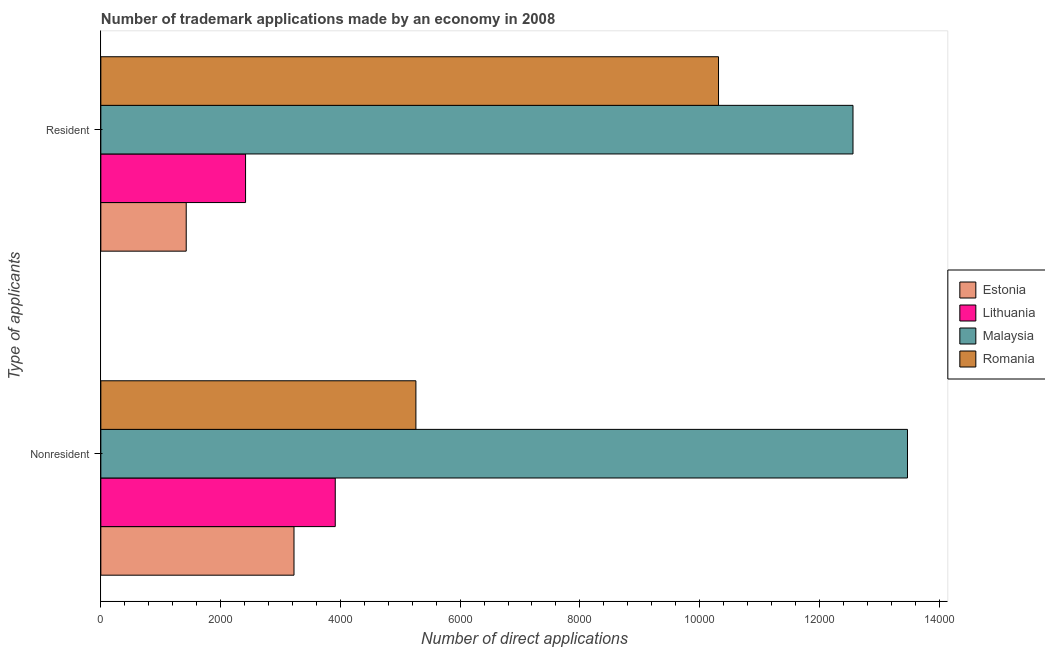How many different coloured bars are there?
Ensure brevity in your answer.  4. How many groups of bars are there?
Offer a very short reply. 2. Are the number of bars on each tick of the Y-axis equal?
Your answer should be compact. Yes. What is the label of the 1st group of bars from the top?
Keep it short and to the point. Resident. What is the number of trademark applications made by non residents in Romania?
Make the answer very short. 5262. Across all countries, what is the maximum number of trademark applications made by residents?
Give a very brief answer. 1.26e+04. Across all countries, what is the minimum number of trademark applications made by residents?
Provide a short and direct response. 1426. In which country was the number of trademark applications made by non residents maximum?
Provide a succinct answer. Malaysia. In which country was the number of trademark applications made by non residents minimum?
Keep it short and to the point. Estonia. What is the total number of trademark applications made by residents in the graph?
Make the answer very short. 2.67e+04. What is the difference between the number of trademark applications made by non residents in Malaysia and that in Estonia?
Your answer should be very brief. 1.02e+04. What is the difference between the number of trademark applications made by non residents in Estonia and the number of trademark applications made by residents in Malaysia?
Offer a terse response. -9336. What is the average number of trademark applications made by residents per country?
Offer a very short reply. 6680.25. What is the difference between the number of trademark applications made by non residents and number of trademark applications made by residents in Estonia?
Make the answer very short. 1800. What is the ratio of the number of trademark applications made by non residents in Estonia to that in Lithuania?
Provide a short and direct response. 0.82. What does the 2nd bar from the top in Resident represents?
Offer a terse response. Malaysia. What does the 4th bar from the bottom in Nonresident represents?
Your response must be concise. Romania. Are all the bars in the graph horizontal?
Provide a short and direct response. Yes. How many countries are there in the graph?
Your response must be concise. 4. Does the graph contain any zero values?
Provide a short and direct response. No. Where does the legend appear in the graph?
Offer a terse response. Center right. How many legend labels are there?
Your response must be concise. 4. What is the title of the graph?
Provide a short and direct response. Number of trademark applications made by an economy in 2008. What is the label or title of the X-axis?
Ensure brevity in your answer.  Number of direct applications. What is the label or title of the Y-axis?
Provide a succinct answer. Type of applicants. What is the Number of direct applications in Estonia in Nonresident?
Make the answer very short. 3226. What is the Number of direct applications in Lithuania in Nonresident?
Offer a terse response. 3915. What is the Number of direct applications of Malaysia in Nonresident?
Keep it short and to the point. 1.35e+04. What is the Number of direct applications in Romania in Nonresident?
Your answer should be compact. 5262. What is the Number of direct applications of Estonia in Resident?
Make the answer very short. 1426. What is the Number of direct applications of Lithuania in Resident?
Your answer should be compact. 2417. What is the Number of direct applications in Malaysia in Resident?
Make the answer very short. 1.26e+04. What is the Number of direct applications of Romania in Resident?
Provide a short and direct response. 1.03e+04. Across all Type of applicants, what is the maximum Number of direct applications in Estonia?
Your response must be concise. 3226. Across all Type of applicants, what is the maximum Number of direct applications in Lithuania?
Your answer should be compact. 3915. Across all Type of applicants, what is the maximum Number of direct applications in Malaysia?
Your answer should be very brief. 1.35e+04. Across all Type of applicants, what is the maximum Number of direct applications of Romania?
Offer a terse response. 1.03e+04. Across all Type of applicants, what is the minimum Number of direct applications in Estonia?
Your answer should be compact. 1426. Across all Type of applicants, what is the minimum Number of direct applications in Lithuania?
Make the answer very short. 2417. Across all Type of applicants, what is the minimum Number of direct applications in Malaysia?
Offer a terse response. 1.26e+04. Across all Type of applicants, what is the minimum Number of direct applications of Romania?
Offer a very short reply. 5262. What is the total Number of direct applications in Estonia in the graph?
Make the answer very short. 4652. What is the total Number of direct applications in Lithuania in the graph?
Provide a short and direct response. 6332. What is the total Number of direct applications in Malaysia in the graph?
Your response must be concise. 2.60e+04. What is the total Number of direct applications in Romania in the graph?
Provide a succinct answer. 1.56e+04. What is the difference between the Number of direct applications of Estonia in Nonresident and that in Resident?
Your answer should be compact. 1800. What is the difference between the Number of direct applications in Lithuania in Nonresident and that in Resident?
Your answer should be compact. 1498. What is the difference between the Number of direct applications in Malaysia in Nonresident and that in Resident?
Offer a terse response. 910. What is the difference between the Number of direct applications of Romania in Nonresident and that in Resident?
Your answer should be compact. -5054. What is the difference between the Number of direct applications in Estonia in Nonresident and the Number of direct applications in Lithuania in Resident?
Make the answer very short. 809. What is the difference between the Number of direct applications of Estonia in Nonresident and the Number of direct applications of Malaysia in Resident?
Give a very brief answer. -9336. What is the difference between the Number of direct applications in Estonia in Nonresident and the Number of direct applications in Romania in Resident?
Your answer should be compact. -7090. What is the difference between the Number of direct applications in Lithuania in Nonresident and the Number of direct applications in Malaysia in Resident?
Make the answer very short. -8647. What is the difference between the Number of direct applications in Lithuania in Nonresident and the Number of direct applications in Romania in Resident?
Give a very brief answer. -6401. What is the difference between the Number of direct applications in Malaysia in Nonresident and the Number of direct applications in Romania in Resident?
Offer a terse response. 3156. What is the average Number of direct applications of Estonia per Type of applicants?
Ensure brevity in your answer.  2326. What is the average Number of direct applications in Lithuania per Type of applicants?
Provide a succinct answer. 3166. What is the average Number of direct applications of Malaysia per Type of applicants?
Your response must be concise. 1.30e+04. What is the average Number of direct applications in Romania per Type of applicants?
Your answer should be compact. 7789. What is the difference between the Number of direct applications in Estonia and Number of direct applications in Lithuania in Nonresident?
Your response must be concise. -689. What is the difference between the Number of direct applications of Estonia and Number of direct applications of Malaysia in Nonresident?
Make the answer very short. -1.02e+04. What is the difference between the Number of direct applications in Estonia and Number of direct applications in Romania in Nonresident?
Provide a succinct answer. -2036. What is the difference between the Number of direct applications in Lithuania and Number of direct applications in Malaysia in Nonresident?
Your response must be concise. -9557. What is the difference between the Number of direct applications in Lithuania and Number of direct applications in Romania in Nonresident?
Your response must be concise. -1347. What is the difference between the Number of direct applications in Malaysia and Number of direct applications in Romania in Nonresident?
Give a very brief answer. 8210. What is the difference between the Number of direct applications in Estonia and Number of direct applications in Lithuania in Resident?
Your response must be concise. -991. What is the difference between the Number of direct applications in Estonia and Number of direct applications in Malaysia in Resident?
Keep it short and to the point. -1.11e+04. What is the difference between the Number of direct applications in Estonia and Number of direct applications in Romania in Resident?
Offer a terse response. -8890. What is the difference between the Number of direct applications in Lithuania and Number of direct applications in Malaysia in Resident?
Offer a very short reply. -1.01e+04. What is the difference between the Number of direct applications of Lithuania and Number of direct applications of Romania in Resident?
Provide a succinct answer. -7899. What is the difference between the Number of direct applications in Malaysia and Number of direct applications in Romania in Resident?
Provide a succinct answer. 2246. What is the ratio of the Number of direct applications of Estonia in Nonresident to that in Resident?
Your answer should be very brief. 2.26. What is the ratio of the Number of direct applications of Lithuania in Nonresident to that in Resident?
Provide a succinct answer. 1.62. What is the ratio of the Number of direct applications of Malaysia in Nonresident to that in Resident?
Offer a very short reply. 1.07. What is the ratio of the Number of direct applications of Romania in Nonresident to that in Resident?
Offer a terse response. 0.51. What is the difference between the highest and the second highest Number of direct applications in Estonia?
Keep it short and to the point. 1800. What is the difference between the highest and the second highest Number of direct applications in Lithuania?
Make the answer very short. 1498. What is the difference between the highest and the second highest Number of direct applications of Malaysia?
Keep it short and to the point. 910. What is the difference between the highest and the second highest Number of direct applications in Romania?
Keep it short and to the point. 5054. What is the difference between the highest and the lowest Number of direct applications in Estonia?
Give a very brief answer. 1800. What is the difference between the highest and the lowest Number of direct applications of Lithuania?
Give a very brief answer. 1498. What is the difference between the highest and the lowest Number of direct applications in Malaysia?
Provide a succinct answer. 910. What is the difference between the highest and the lowest Number of direct applications in Romania?
Ensure brevity in your answer.  5054. 